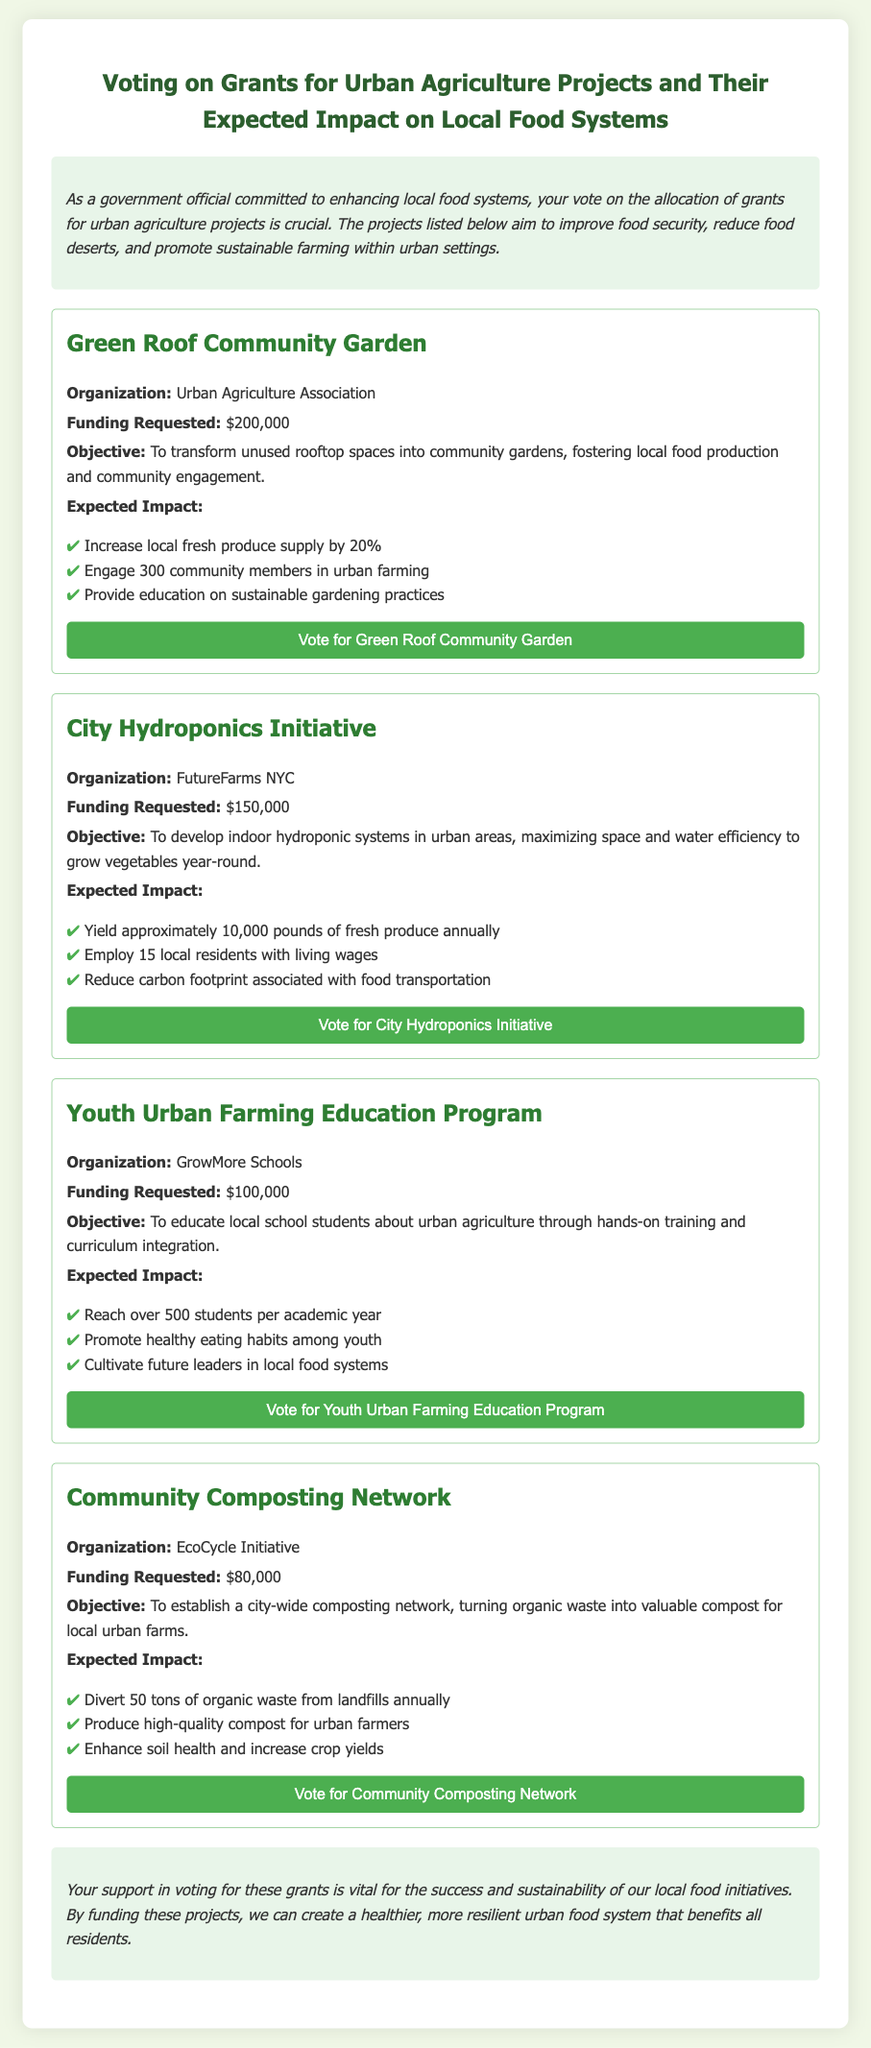what is the title of the document? The title is prominently displayed at the top of the document.
Answer: Voting on Grants for Urban Agriculture Projects and Their Expected Impact on Local Food Systems how much funding is requested for the Green Roof Community Garden? This information is found in the specific grant proposal for the Green Roof Community Garden.
Answer: $200,000 who is the organization behind the City Hydroponics Initiative? The organization name is listed under the City Hydroponics Initiative section in the document.
Answer: FutureFarms NYC what is the expected annual yield of the City Hydroponics Initiative? The yield amount is specified in the expected impact section of the City Hydroponics Initiative proposal.
Answer: approximately 10,000 pounds how many students does the Youth Urban Farming Education Program aim to reach per academic year? This number is provided in the expected impact section of the Youth Urban Farming Education Program.
Answer: over 500 students what is the objective of the Community Composting Network? The objective is stated in the Community Composting Network section describing its purpose.
Answer: To establish a city-wide composting network which grant proposal has the lowest funding request? The funding requested is listed for each proposal, and the lowest amount can be identified accordingly.
Answer: $80,000 how many community members does the Green Roof Community Garden aim to engage? This figure can be found in the expected impact section of the Green Roof Community Garden proposal.
Answer: 300 community members what is the main goal of the Youth Urban Farming Education Program? This goal is mentioned in the objective of the Youth Urban Farming Education Program.
Answer: To educate local school students about urban agriculture 